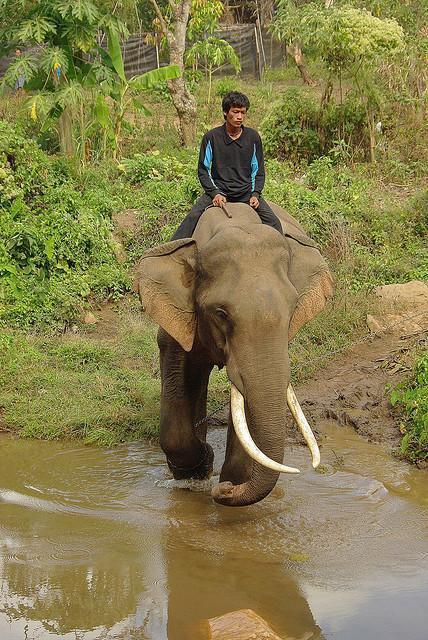How many people are riding the elephant?
Give a very brief answer. 1. How many laptops are on the desk?
Give a very brief answer. 0. 